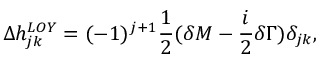<formula> <loc_0><loc_0><loc_500><loc_500>\Delta h _ { j k } ^ { L O Y } = ( - 1 ) ^ { j + 1 } \frac { 1 } { 2 } ( \delta M - \frac { i } { 2 } \delta \Gamma ) { \delta } _ { j k } ,</formula> 